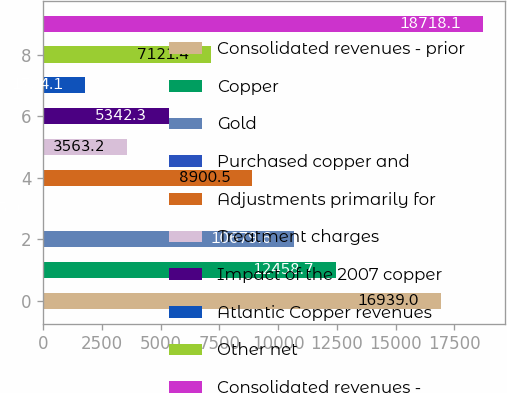Convert chart to OTSL. <chart><loc_0><loc_0><loc_500><loc_500><bar_chart><fcel>Consolidated revenues - prior<fcel>Copper<fcel>Gold<fcel>Purchased copper and<fcel>Adjustments primarily for<fcel>Treatment charges<fcel>Impact of the 2007 copper<fcel>Atlantic Copper revenues<fcel>Other net<fcel>Consolidated revenues -<nl><fcel>16939<fcel>12458.7<fcel>10679.6<fcel>5<fcel>8900.5<fcel>3563.2<fcel>5342.3<fcel>1784.1<fcel>7121.4<fcel>18718.1<nl></chart> 